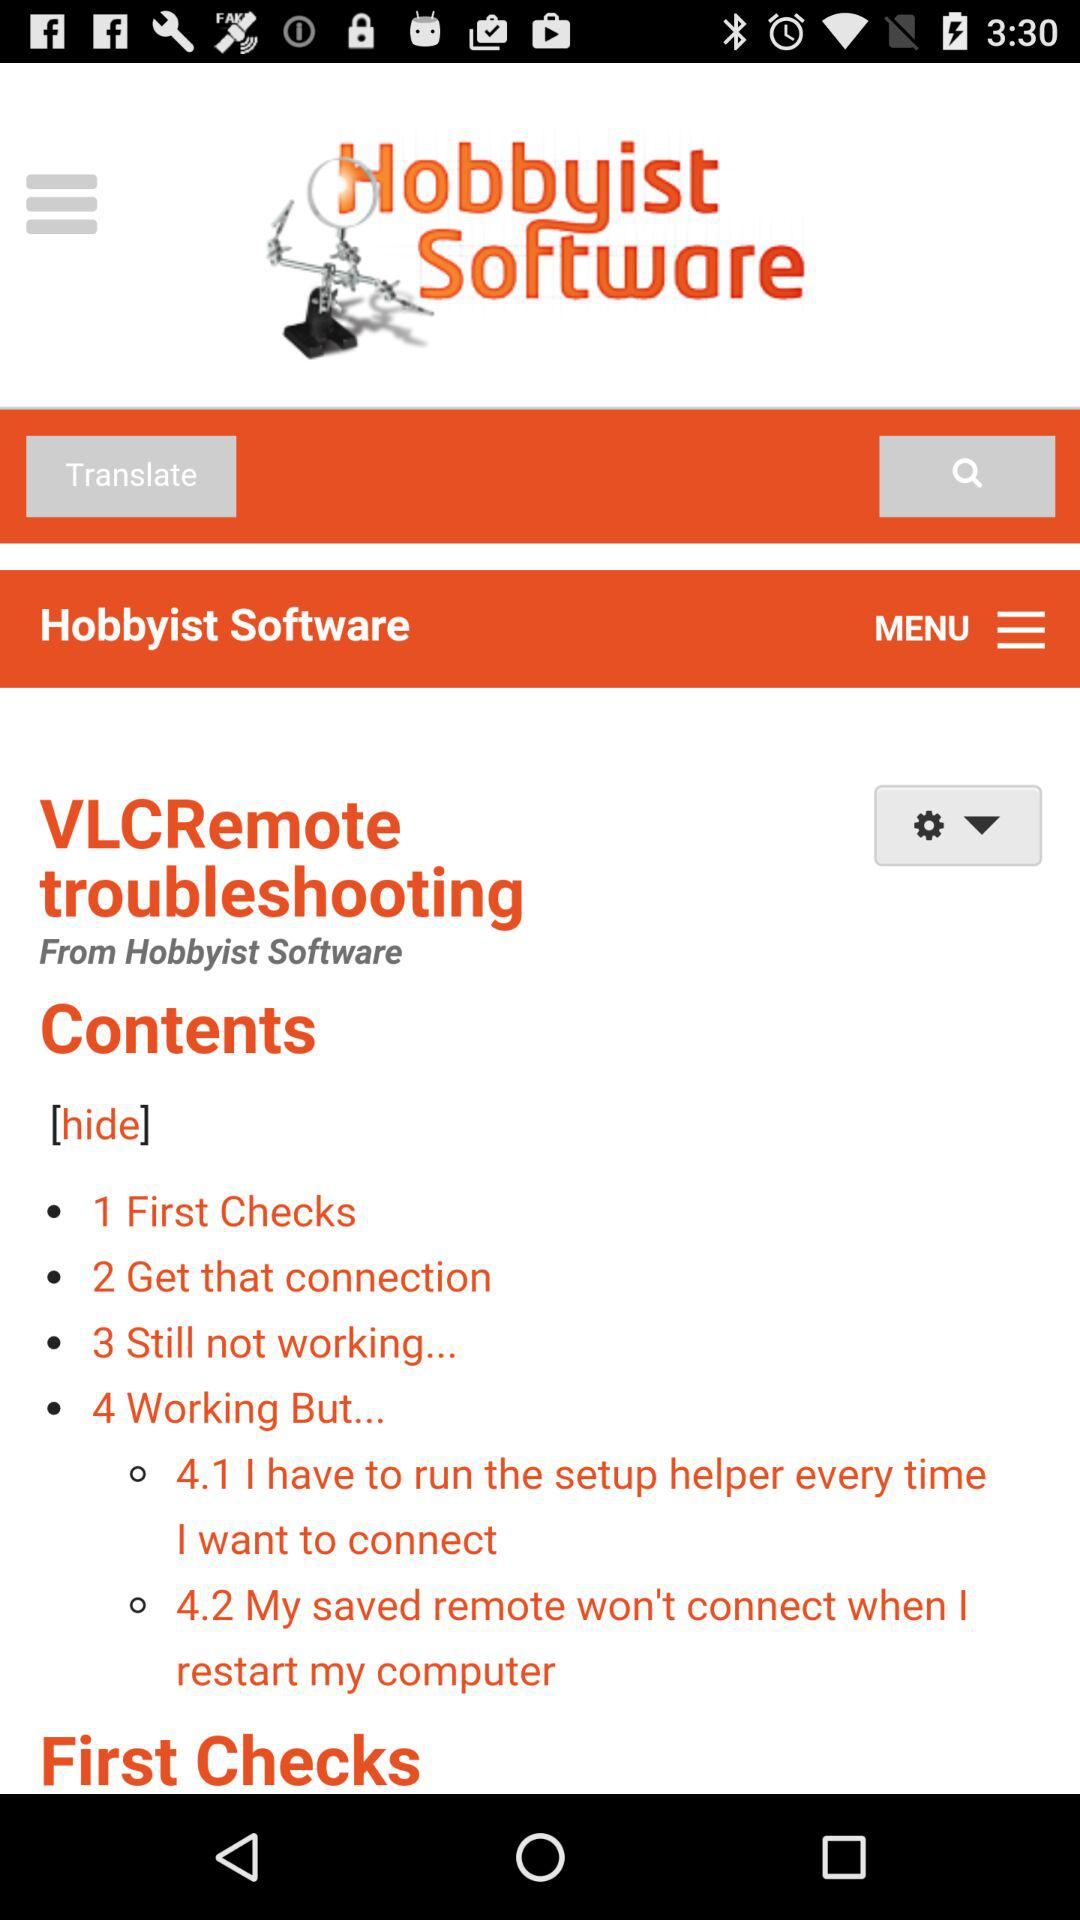How many sections are there in the troubleshooting guide?
Answer the question using a single word or phrase. 4 